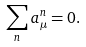<formula> <loc_0><loc_0><loc_500><loc_500>\sum _ { n } a ^ { n } _ { \mu } = 0 .</formula> 